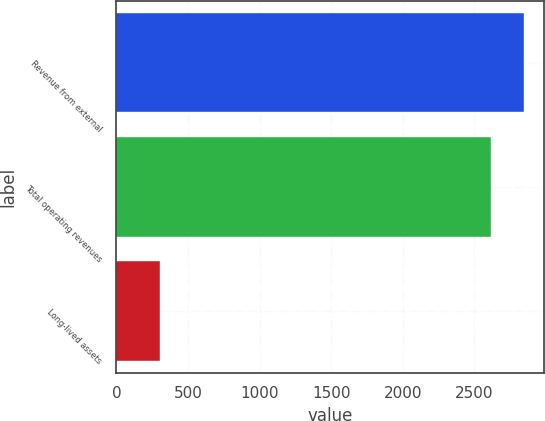<chart> <loc_0><loc_0><loc_500><loc_500><bar_chart><fcel>Revenue from external<fcel>Total operating revenues<fcel>Long-lived assets<nl><fcel>2845.04<fcel>2613.5<fcel>306.7<nl></chart> 